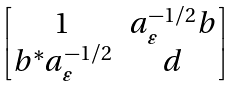<formula> <loc_0><loc_0><loc_500><loc_500>\begin{bmatrix} 1 & a _ { \varepsilon } ^ { - 1 / 2 } b \\ b ^ { * } a _ { \varepsilon } ^ { - 1 / 2 } & d \end{bmatrix}</formula> 